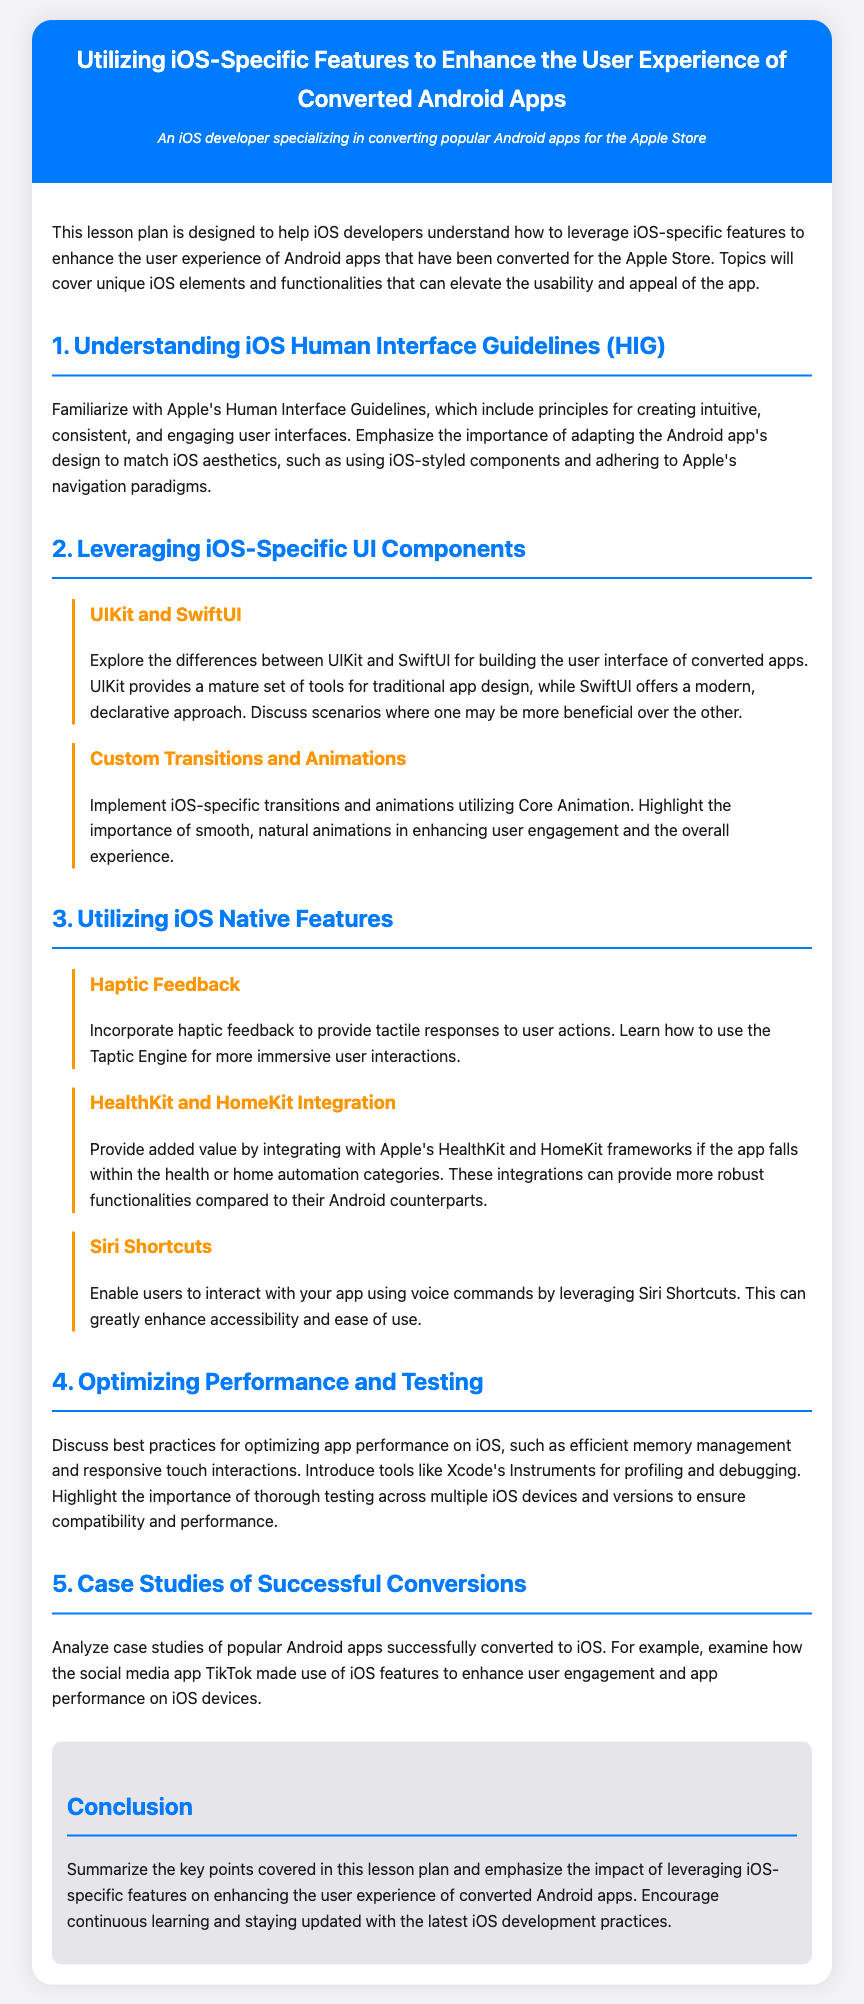What is the title of the lesson plan? The title is the main heading of the document, which encapsulates the focus of the content provided.
Answer: Utilizing iOS-Specific Features to Enhance the User Experience of Converted Android Apps What are the two UI frameworks discussed in the lesson plan? The document mentions two frameworks for building user interfaces, emphasizing their roles in app development.
Answer: UIKit and SwiftUI Which feature involves providing tactile responses to user actions? This feature is highlighted as a way to enhance user interactivity through physical feedback.
Answer: Haptic Feedback What is one best practice mentioned for optimizing app performance on iOS? This practice is essential for maintaining a smooth user experience and is advised in the performance section of the document.
Answer: Efficient memory management Name a framework that can be integrated for health-related apps. This framework is noted for providing robust functionalities in the health sector when converted to iOS.
Answer: HealthKit How does the lesson plan suggest enhancing user interaction through voice? This approach is focused on accessibility and ease of use for app users on iOS.
Answer: Siri Shortcuts What does the HIG stand for in the context of this lesson plan? HIG is an acronym used in the document when referring to a specific set of guidelines crucial for iOS development.
Answer: Human Interface Guidelines What is the main goal of the lesson plan? The overall purpose defined in the introduction provides insight into the intent of educating developers on specific features.
Answer: Enhance the user experience of converted Android apps 